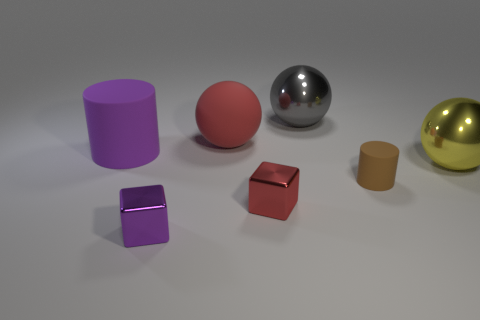Add 1 large cyan rubber cubes. How many objects exist? 8 Subtract all metallic spheres. How many spheres are left? 1 Subtract all cylinders. How many objects are left? 5 Add 2 yellow objects. How many yellow objects are left? 3 Add 2 cyan cylinders. How many cyan cylinders exist? 2 Subtract 0 gray cylinders. How many objects are left? 7 Subtract all blue balls. Subtract all green cylinders. How many balls are left? 3 Subtract all metal cubes. Subtract all green rubber objects. How many objects are left? 5 